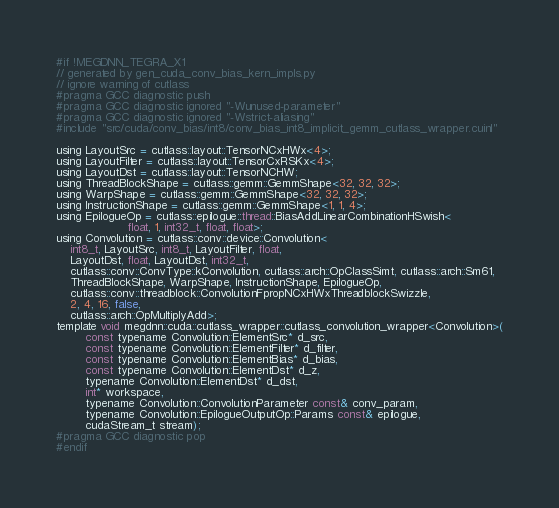Convert code to text. <code><loc_0><loc_0><loc_500><loc_500><_Cuda_>#if !MEGDNN_TEGRA_X1
// generated by gen_cuda_conv_bias_kern_impls.py
// ignore warning of cutlass
#pragma GCC diagnostic push
#pragma GCC diagnostic ignored "-Wunused-parameter"
#pragma GCC diagnostic ignored "-Wstrict-aliasing"
#include "src/cuda/conv_bias/int8/conv_bias_int8_implicit_gemm_cutlass_wrapper.cuinl"

using LayoutSrc = cutlass::layout::TensorNCxHWx<4>;
using LayoutFilter = cutlass::layout::TensorCxRSKx<4>;
using LayoutDst = cutlass::layout::TensorNCHW;
using ThreadBlockShape = cutlass::gemm::GemmShape<32, 32, 32>;
using WarpShape = cutlass::gemm::GemmShape<32, 32, 32>;
using InstructionShape = cutlass::gemm::GemmShape<1, 1, 4>;
using EpilogueOp = cutlass::epilogue::thread::BiasAddLinearCombinationHSwish<
                    float, 1, int32_t, float, float>;
using Convolution = cutlass::conv::device::Convolution<
    int8_t, LayoutSrc, int8_t, LayoutFilter, float, 
    LayoutDst, float, LayoutDst, int32_t, 
    cutlass::conv::ConvType::kConvolution, cutlass::arch::OpClassSimt, cutlass::arch::Sm61, 
    ThreadBlockShape, WarpShape, InstructionShape, EpilogueOp, 
    cutlass::conv::threadblock::ConvolutionFpropNCxHWxThreadblockSwizzle, 
    2, 4, 16, false, 
    cutlass::arch::OpMultiplyAdd>;
template void megdnn::cuda::cutlass_wrapper::cutlass_convolution_wrapper<Convolution>(
        const typename Convolution::ElementSrc* d_src, 
        const typename Convolution::ElementFilter* d_filter, 
        const typename Convolution::ElementBias* d_bias, 
        const typename Convolution::ElementDst* d_z, 
        typename Convolution::ElementDst* d_dst, 
        int* workspace, 
        typename Convolution::ConvolutionParameter const& conv_param, 
        typename Convolution::EpilogueOutputOp::Params const& epilogue, 
        cudaStream_t stream);
#pragma GCC diagnostic pop
#endif
</code> 